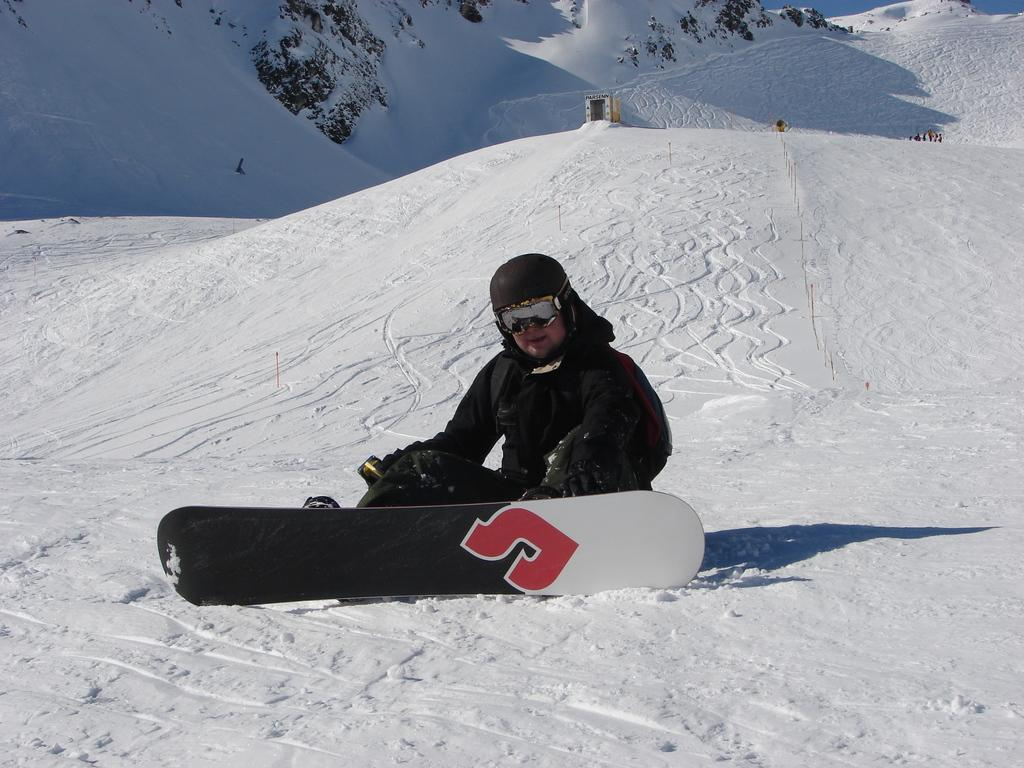What object is located in the foreground of the image? There is a skateboard in the foreground of the image. What is the man in the foreground doing? The man is sitting on the snow in the foreground. What type of natural environment is visible in the background of the image? There is snow and trees visible in the background of the image. What is visible at the top of the image? The sky is visible at the top of the image. What type of doll can be seen having a negative effect on the man in the image? There is no doll present in the image, and therefore no such interaction can be observed. What type of poison is visible in the image? There is no poison present in the image. 